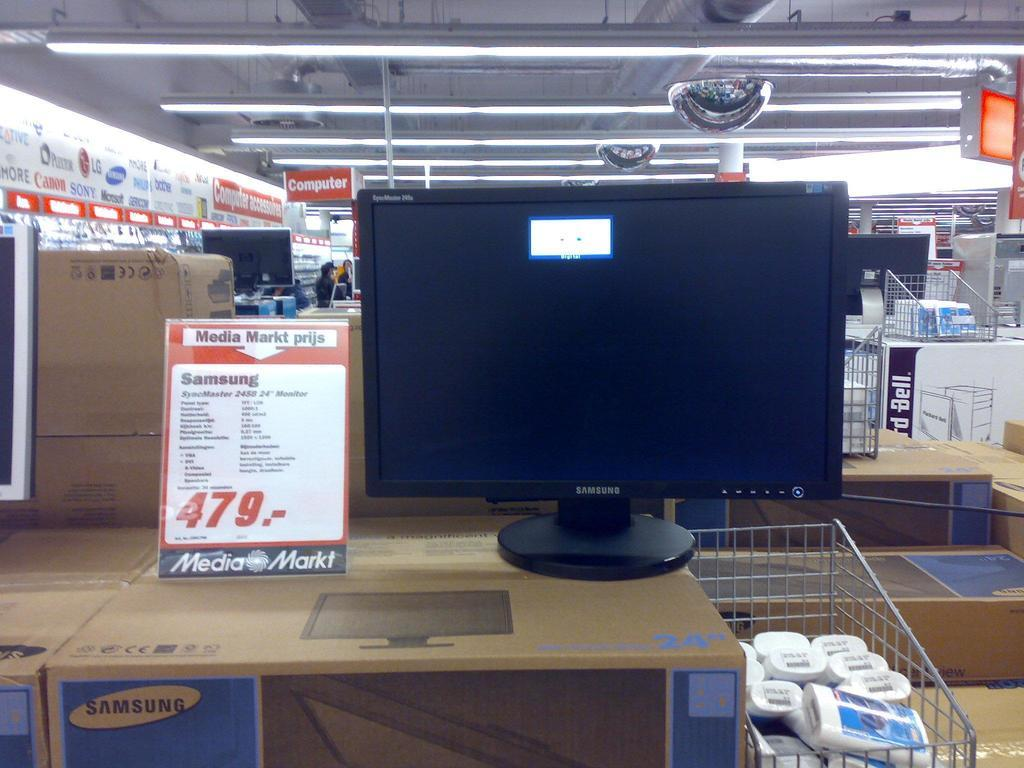<image>
Write a terse but informative summary of the picture. a sign next to a computer screen that says media markt prijs 